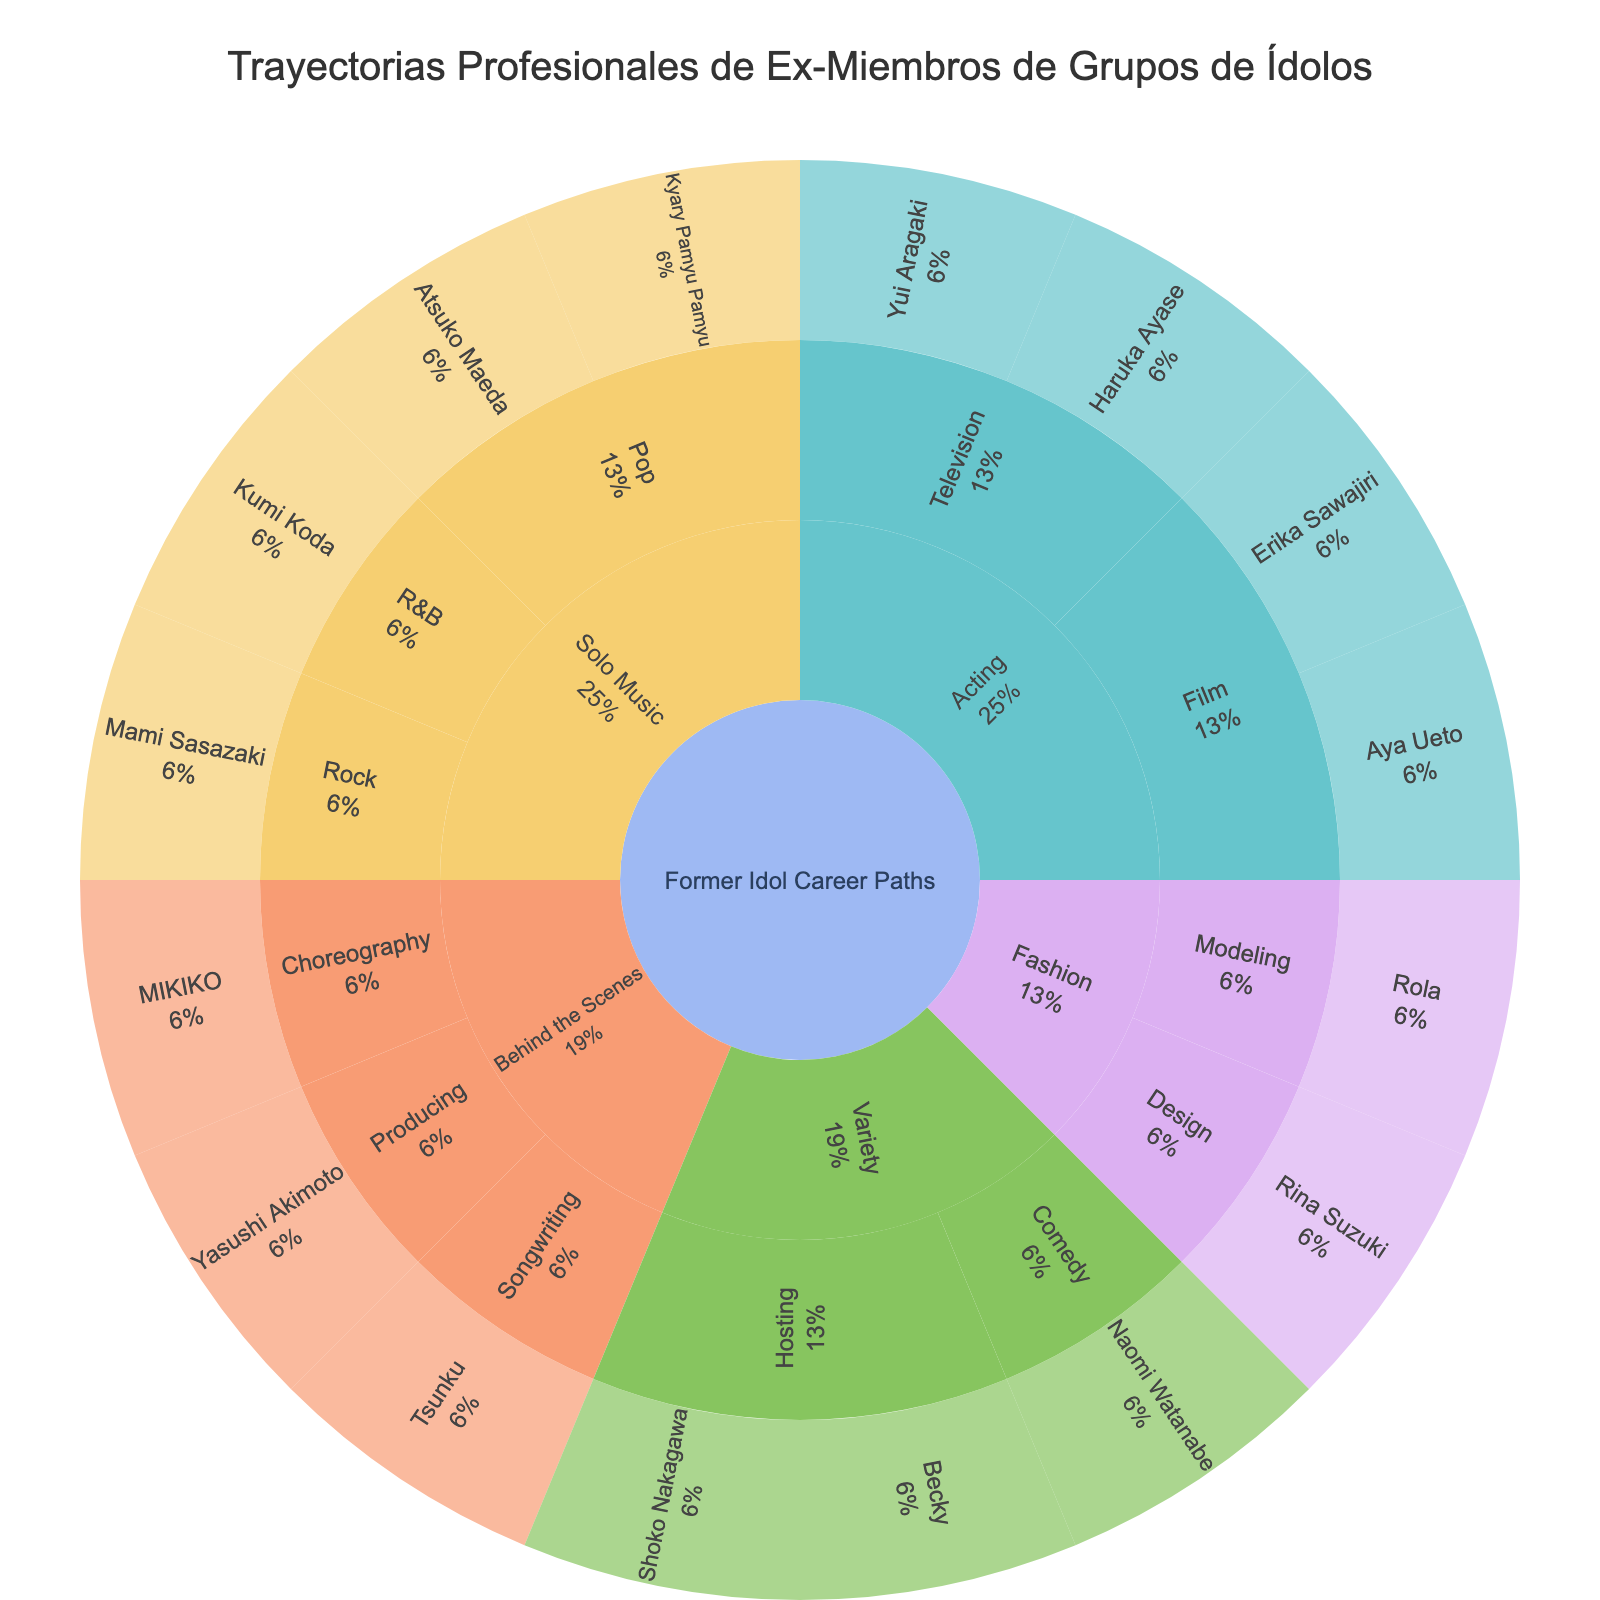What's the primary title of the figure? The title of a plot is typically displayed prominently at the top of the image. In this case, it is customized in the code.
Answer: Trayectorias Profesionales de Ex-Miembros de Grupos de Ídolos How many individuals have transitioned into Solo Music careers? In the Sunburst plot, the Solo Music category contains Pop, Rock, and R&B subcategories. Counting the individuals in each subcategory: Pop (2), Rock (1), R&B (1); total is 2 + 1 + 1.
Answer: 4 Which category has more individuals: Acting or Variety? Count the number of individuals in the subcategories under Acting and Variety. Acting has Film (2) and Television (2) summing to 4. Variety has Hosting (2) and Comedy (1) summing to 3.
Answer: Acting Is there a more popular career path among former idols in the Fashion category? In the Fashion category, compare the Modeling and Design subcategories. Each subcategory has one individual (Modeling: Rola, Design: Rina Suzuki). Since they are equal, there's no clear more popular path.
Answer: No Who are the two individuals in the Film subcategory under Acting? The Sunburst plot will show this information when you follow the path from Acting to Film. The two individuals listed are Aya Ueto and Erika Sawajiri.
Answer: Aya Ueto and Erika Sawajiri What percentage of individuals transitioned into the Pop subcategory under Solo Music? The Sunburst plot typically shows percentage information. Pop within Solo Music has 2 individuals. There are 16 individuals in total in the dataset. The percentage is (2/16) * 100.
Answer: 12.5% Which career category does Yasushi Akimoto belong to? Trace Yasushi Akimoto’s path in the Sunburst plot to find that he is categorized under Behind the Scenes in the Producing subcategory.
Answer: Behind the Scenes Compare the number of individuals in the Hosting subcategory of Variety to the number in the Television subcategory of Acting Hosting in Variety has 2 individuals (Becky and Shoko Nakagawa), and Television in Acting also has 2 individuals (Haruka Ayase and Yui Aragaki).
Answer: Equal How many individuals does the Fashion category have compared to Behind the Scenes? Fashion consists of Modeling (1) and Design (1), making a total of 2. Behind the Scenes includes Producing (1), Choreography (1), and Songwriting (1), making a total of 3.
Answer: Behind the Scenes What subcategory does the individual Rina Suzuki belong to? The Sunburst plot shows Rina Suzuki under the path follows from the root to Fashion and then to Design.
Answer: Design 